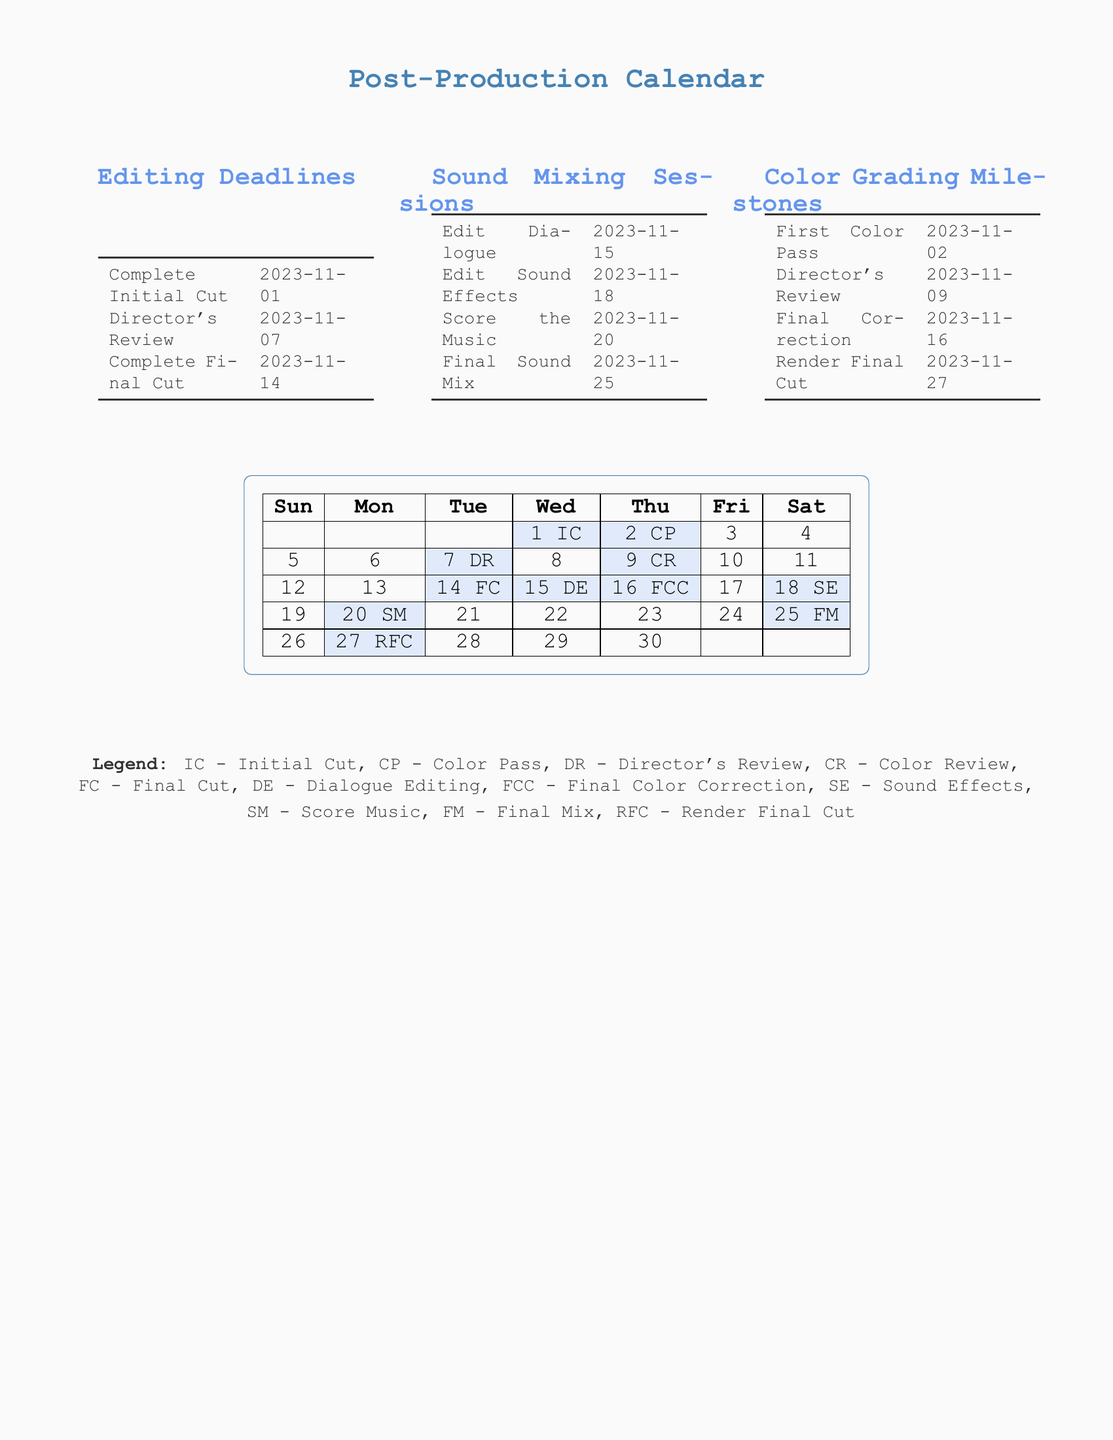What is the deadline for the Complete Initial Cut? The deadline for the Complete Initial Cut is specified in the Editing Deadlines section of the document.
Answer: 2023-11-01 When is the Director's Review scheduled? The Director's Review date is found within the Editing Deadlines section of the document.
Answer: 2023-11-07 What is the last date for sound mixing? The last date for sound mixing is indicated in the Sound Mixing Sessions section of the document.
Answer: 2023-11-25 How many days are there between the First Color Pass and the Final Correction? To find the number of days between these two milestones, one would note the dates in the Color Grading Milestones.
Answer: 14 What does 'SM' stand for in the calendar legend? The legend explains the abbreviations used in the timeline.
Answer: Score Music When does the Final Correction of the color grading occur? This information can be found under the Color Grading Milestones section in the document.
Answer: 2023-11-16 How many total sound mixing sessions are planned? By counting the entries in the Sound Mixing Sessions section, the total number can be determined.
Answer: 4 What is the purpose of the 'Legend' section in this document? The Legend provides explanations for the acronyms used throughout the calendar.
Answer: Explanations for acronyms Which milestone follows the Complete Final Cut? This is a reasoning question that requires looking beyond just the Editing Deadlines and considering all milestones.
Answer: 2023-11-15 DE 